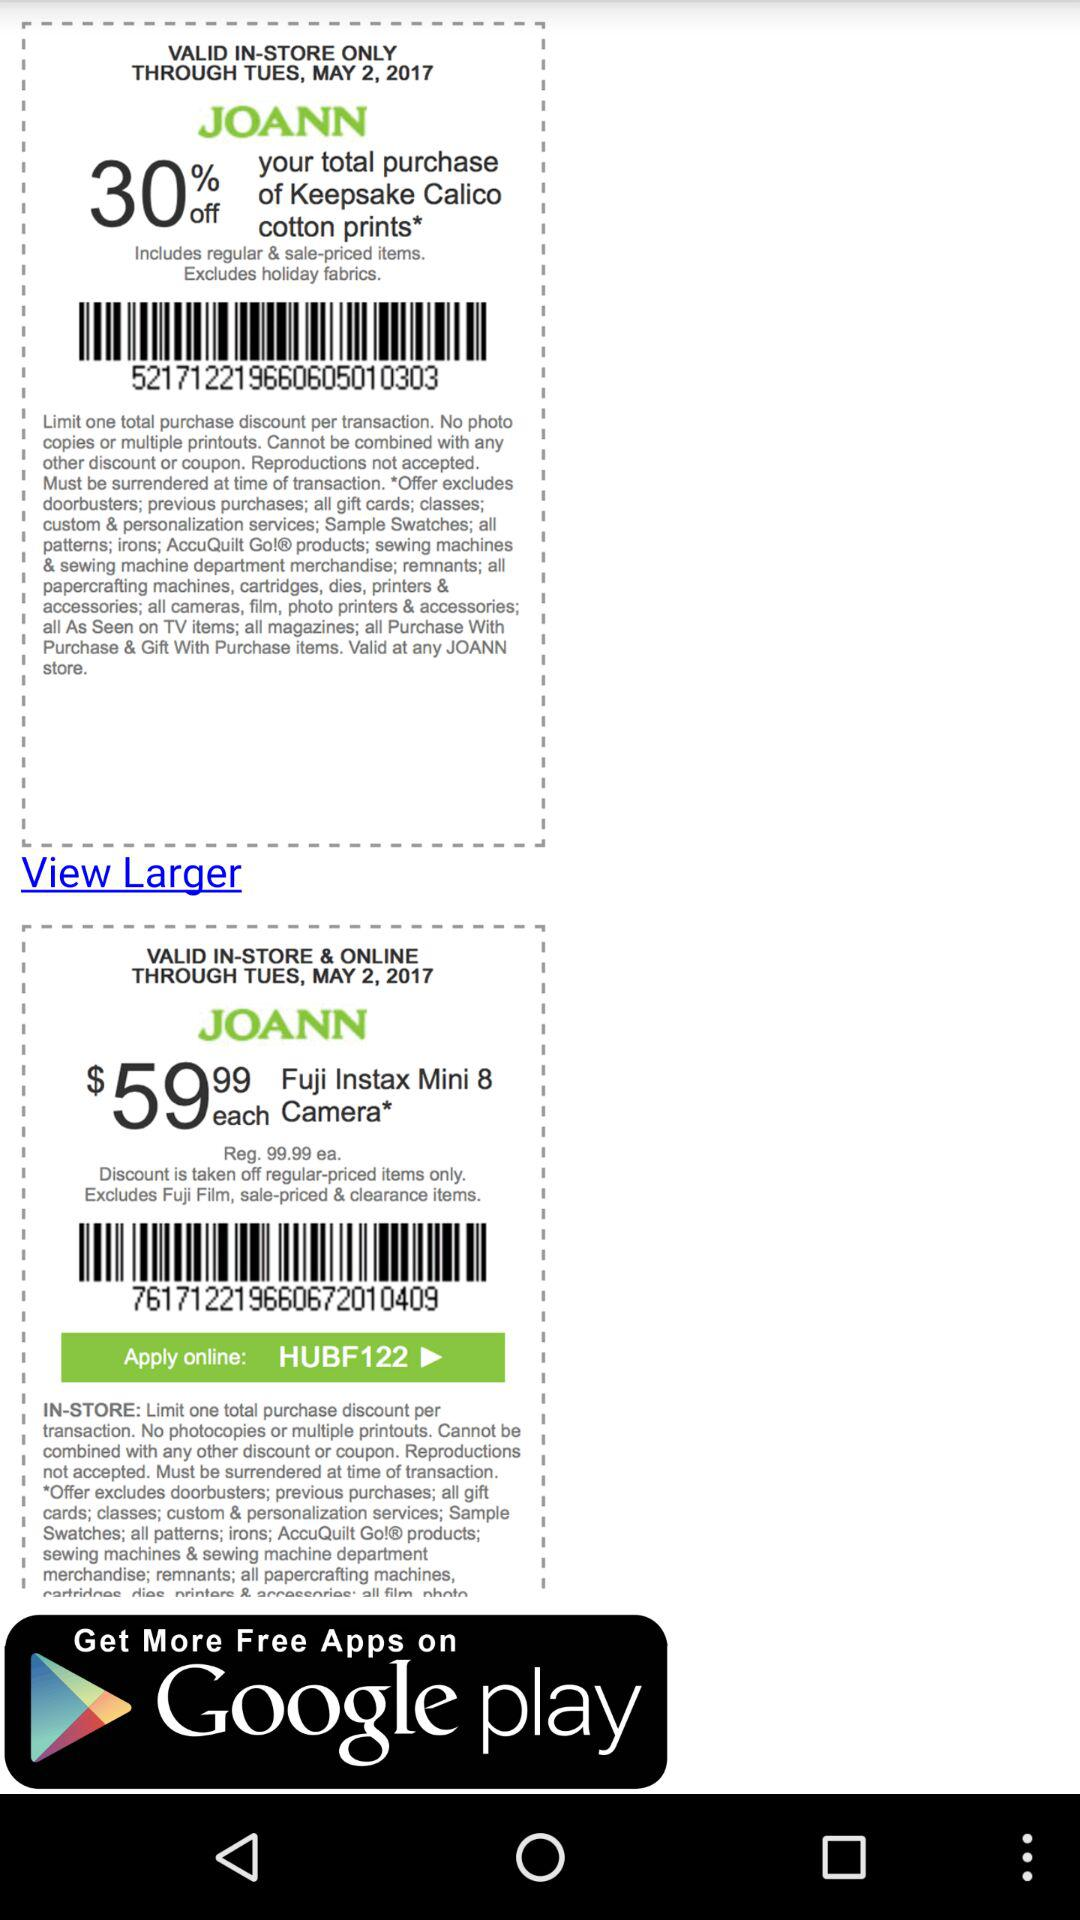Where is the nearest store location?
When the provided information is insufficient, respond with <no answer>. <no answer> 